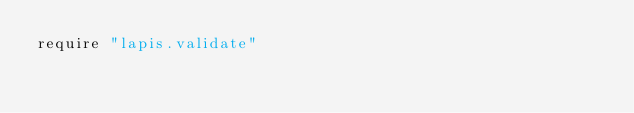Convert code to text. <code><loc_0><loc_0><loc_500><loc_500><_MoonScript_>require "lapis.validate"</code> 